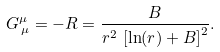<formula> <loc_0><loc_0><loc_500><loc_500>G ^ { \mu } _ { \, \mu } = - R = \frac { B } { r ^ { 2 } \, \left [ \ln ( r ) + B \right ] ^ { 2 } } .</formula> 